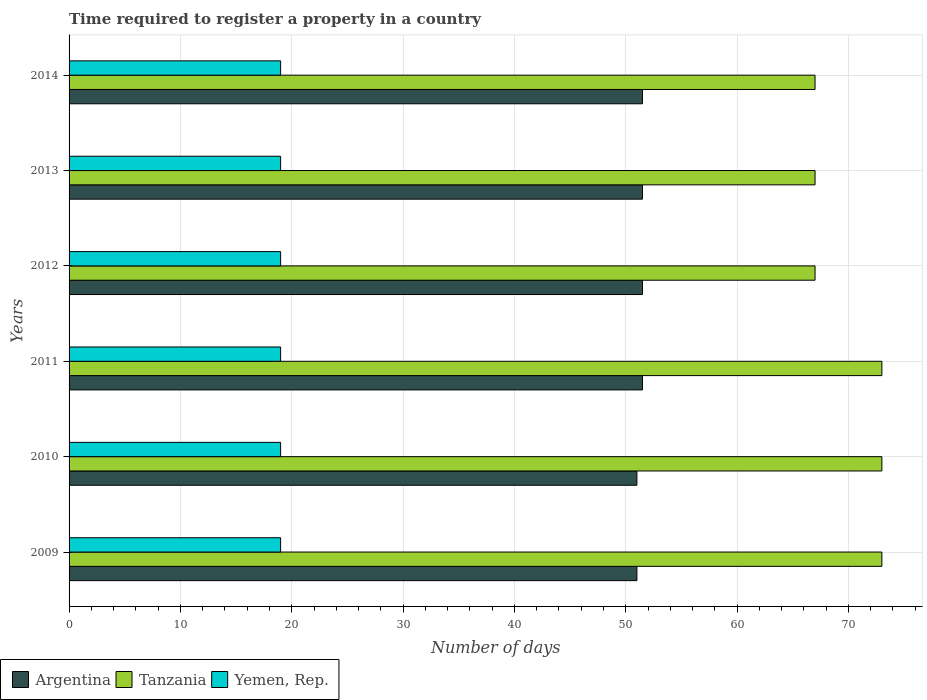How many different coloured bars are there?
Provide a succinct answer. 3. How many bars are there on the 3rd tick from the top?
Make the answer very short. 3. How many bars are there on the 6th tick from the bottom?
Offer a very short reply. 3. In how many cases, is the number of bars for a given year not equal to the number of legend labels?
Your answer should be compact. 0. Across all years, what is the maximum number of days required to register a property in Yemen, Rep.?
Keep it short and to the point. 19. Across all years, what is the minimum number of days required to register a property in Argentina?
Keep it short and to the point. 51. In which year was the number of days required to register a property in Tanzania minimum?
Give a very brief answer. 2012. What is the total number of days required to register a property in Argentina in the graph?
Ensure brevity in your answer.  308. What is the difference between the number of days required to register a property in Yemen, Rep. in 2011 and that in 2013?
Your response must be concise. 0. What is the difference between the number of days required to register a property in Yemen, Rep. in 2010 and the number of days required to register a property in Argentina in 2012?
Offer a terse response. -32.5. What is the ratio of the number of days required to register a property in Yemen, Rep. in 2009 to that in 2010?
Provide a short and direct response. 1. Is the number of days required to register a property in Argentina in 2011 less than that in 2014?
Your answer should be compact. No. Is the difference between the number of days required to register a property in Tanzania in 2012 and 2013 greater than the difference between the number of days required to register a property in Argentina in 2012 and 2013?
Offer a terse response. No. What is the difference between the highest and the second highest number of days required to register a property in Yemen, Rep.?
Offer a terse response. 0. Is the sum of the number of days required to register a property in Yemen, Rep. in 2010 and 2013 greater than the maximum number of days required to register a property in Tanzania across all years?
Provide a succinct answer. No. What does the 3rd bar from the bottom in 2012 represents?
Your answer should be very brief. Yemen, Rep. Are the values on the major ticks of X-axis written in scientific E-notation?
Your answer should be compact. No. Does the graph contain any zero values?
Ensure brevity in your answer.  No. Does the graph contain grids?
Keep it short and to the point. Yes. Where does the legend appear in the graph?
Your answer should be very brief. Bottom left. What is the title of the graph?
Your response must be concise. Time required to register a property in a country. What is the label or title of the X-axis?
Make the answer very short. Number of days. What is the label or title of the Y-axis?
Provide a succinct answer. Years. What is the Number of days in Tanzania in 2010?
Give a very brief answer. 73. What is the Number of days of Argentina in 2011?
Provide a succinct answer. 51.5. What is the Number of days in Argentina in 2012?
Provide a succinct answer. 51.5. What is the Number of days of Yemen, Rep. in 2012?
Give a very brief answer. 19. What is the Number of days of Argentina in 2013?
Provide a succinct answer. 51.5. What is the Number of days in Yemen, Rep. in 2013?
Give a very brief answer. 19. What is the Number of days of Argentina in 2014?
Provide a succinct answer. 51.5. What is the Number of days in Yemen, Rep. in 2014?
Your answer should be compact. 19. Across all years, what is the maximum Number of days in Argentina?
Keep it short and to the point. 51.5. Across all years, what is the maximum Number of days in Yemen, Rep.?
Your answer should be very brief. 19. Across all years, what is the minimum Number of days of Tanzania?
Your answer should be very brief. 67. Across all years, what is the minimum Number of days in Yemen, Rep.?
Your answer should be very brief. 19. What is the total Number of days in Argentina in the graph?
Offer a very short reply. 308. What is the total Number of days in Tanzania in the graph?
Give a very brief answer. 420. What is the total Number of days of Yemen, Rep. in the graph?
Keep it short and to the point. 114. What is the difference between the Number of days of Argentina in 2009 and that in 2010?
Your answer should be very brief. 0. What is the difference between the Number of days in Yemen, Rep. in 2009 and that in 2010?
Provide a succinct answer. 0. What is the difference between the Number of days in Yemen, Rep. in 2009 and that in 2011?
Offer a very short reply. 0. What is the difference between the Number of days in Argentina in 2009 and that in 2012?
Keep it short and to the point. -0.5. What is the difference between the Number of days of Argentina in 2009 and that in 2013?
Your answer should be compact. -0.5. What is the difference between the Number of days in Yemen, Rep. in 2009 and that in 2013?
Offer a very short reply. 0. What is the difference between the Number of days in Tanzania in 2009 and that in 2014?
Provide a succinct answer. 6. What is the difference between the Number of days of Yemen, Rep. in 2009 and that in 2014?
Offer a very short reply. 0. What is the difference between the Number of days in Argentina in 2010 and that in 2012?
Your answer should be compact. -0.5. What is the difference between the Number of days of Tanzania in 2010 and that in 2013?
Your answer should be very brief. 6. What is the difference between the Number of days of Argentina in 2010 and that in 2014?
Make the answer very short. -0.5. What is the difference between the Number of days of Tanzania in 2010 and that in 2014?
Offer a terse response. 6. What is the difference between the Number of days of Yemen, Rep. in 2010 and that in 2014?
Make the answer very short. 0. What is the difference between the Number of days in Argentina in 2011 and that in 2012?
Your answer should be compact. 0. What is the difference between the Number of days in Argentina in 2011 and that in 2013?
Provide a short and direct response. 0. What is the difference between the Number of days of Yemen, Rep. in 2011 and that in 2013?
Keep it short and to the point. 0. What is the difference between the Number of days of Tanzania in 2012 and that in 2014?
Your response must be concise. 0. What is the difference between the Number of days of Yemen, Rep. in 2012 and that in 2014?
Your answer should be compact. 0. What is the difference between the Number of days in Argentina in 2013 and that in 2014?
Make the answer very short. 0. What is the difference between the Number of days of Tanzania in 2013 and that in 2014?
Provide a succinct answer. 0. What is the difference between the Number of days in Argentina in 2009 and the Number of days in Tanzania in 2010?
Give a very brief answer. -22. What is the difference between the Number of days in Tanzania in 2009 and the Number of days in Yemen, Rep. in 2011?
Provide a short and direct response. 54. What is the difference between the Number of days in Argentina in 2009 and the Number of days in Tanzania in 2012?
Your answer should be very brief. -16. What is the difference between the Number of days of Argentina in 2009 and the Number of days of Yemen, Rep. in 2012?
Keep it short and to the point. 32. What is the difference between the Number of days of Argentina in 2009 and the Number of days of Tanzania in 2013?
Your answer should be very brief. -16. What is the difference between the Number of days of Tanzania in 2009 and the Number of days of Yemen, Rep. in 2013?
Give a very brief answer. 54. What is the difference between the Number of days in Argentina in 2009 and the Number of days in Tanzania in 2014?
Your answer should be very brief. -16. What is the difference between the Number of days in Argentina in 2009 and the Number of days in Yemen, Rep. in 2014?
Provide a succinct answer. 32. What is the difference between the Number of days in Tanzania in 2010 and the Number of days in Yemen, Rep. in 2011?
Your answer should be compact. 54. What is the difference between the Number of days of Argentina in 2010 and the Number of days of Tanzania in 2012?
Ensure brevity in your answer.  -16. What is the difference between the Number of days of Tanzania in 2010 and the Number of days of Yemen, Rep. in 2012?
Your answer should be very brief. 54. What is the difference between the Number of days of Tanzania in 2010 and the Number of days of Yemen, Rep. in 2014?
Provide a succinct answer. 54. What is the difference between the Number of days in Argentina in 2011 and the Number of days in Tanzania in 2012?
Provide a short and direct response. -15.5. What is the difference between the Number of days of Argentina in 2011 and the Number of days of Yemen, Rep. in 2012?
Provide a short and direct response. 32.5. What is the difference between the Number of days in Argentina in 2011 and the Number of days in Tanzania in 2013?
Provide a succinct answer. -15.5. What is the difference between the Number of days of Argentina in 2011 and the Number of days of Yemen, Rep. in 2013?
Your answer should be very brief. 32.5. What is the difference between the Number of days of Argentina in 2011 and the Number of days of Tanzania in 2014?
Keep it short and to the point. -15.5. What is the difference between the Number of days in Argentina in 2011 and the Number of days in Yemen, Rep. in 2014?
Keep it short and to the point. 32.5. What is the difference between the Number of days in Argentina in 2012 and the Number of days in Tanzania in 2013?
Provide a succinct answer. -15.5. What is the difference between the Number of days in Argentina in 2012 and the Number of days in Yemen, Rep. in 2013?
Give a very brief answer. 32.5. What is the difference between the Number of days of Argentina in 2012 and the Number of days of Tanzania in 2014?
Provide a short and direct response. -15.5. What is the difference between the Number of days in Argentina in 2012 and the Number of days in Yemen, Rep. in 2014?
Offer a very short reply. 32.5. What is the difference between the Number of days of Argentina in 2013 and the Number of days of Tanzania in 2014?
Your answer should be compact. -15.5. What is the difference between the Number of days in Argentina in 2013 and the Number of days in Yemen, Rep. in 2014?
Make the answer very short. 32.5. What is the average Number of days in Argentina per year?
Give a very brief answer. 51.33. What is the average Number of days of Tanzania per year?
Provide a succinct answer. 70. What is the average Number of days in Yemen, Rep. per year?
Provide a succinct answer. 19. In the year 2009, what is the difference between the Number of days in Argentina and Number of days in Yemen, Rep.?
Offer a terse response. 32. In the year 2009, what is the difference between the Number of days in Tanzania and Number of days in Yemen, Rep.?
Your answer should be compact. 54. In the year 2010, what is the difference between the Number of days of Argentina and Number of days of Tanzania?
Ensure brevity in your answer.  -22. In the year 2011, what is the difference between the Number of days of Argentina and Number of days of Tanzania?
Provide a short and direct response. -21.5. In the year 2011, what is the difference between the Number of days of Argentina and Number of days of Yemen, Rep.?
Keep it short and to the point. 32.5. In the year 2012, what is the difference between the Number of days of Argentina and Number of days of Tanzania?
Make the answer very short. -15.5. In the year 2012, what is the difference between the Number of days in Argentina and Number of days in Yemen, Rep.?
Provide a short and direct response. 32.5. In the year 2013, what is the difference between the Number of days in Argentina and Number of days in Tanzania?
Provide a short and direct response. -15.5. In the year 2013, what is the difference between the Number of days of Argentina and Number of days of Yemen, Rep.?
Offer a very short reply. 32.5. In the year 2014, what is the difference between the Number of days in Argentina and Number of days in Tanzania?
Provide a succinct answer. -15.5. In the year 2014, what is the difference between the Number of days of Argentina and Number of days of Yemen, Rep.?
Ensure brevity in your answer.  32.5. What is the ratio of the Number of days in Argentina in 2009 to that in 2010?
Give a very brief answer. 1. What is the ratio of the Number of days in Tanzania in 2009 to that in 2010?
Your answer should be compact. 1. What is the ratio of the Number of days in Argentina in 2009 to that in 2011?
Make the answer very short. 0.99. What is the ratio of the Number of days of Argentina in 2009 to that in 2012?
Your response must be concise. 0.99. What is the ratio of the Number of days of Tanzania in 2009 to that in 2012?
Keep it short and to the point. 1.09. What is the ratio of the Number of days in Argentina in 2009 to that in 2013?
Provide a succinct answer. 0.99. What is the ratio of the Number of days in Tanzania in 2009 to that in 2013?
Provide a succinct answer. 1.09. What is the ratio of the Number of days of Argentina in 2009 to that in 2014?
Offer a terse response. 0.99. What is the ratio of the Number of days of Tanzania in 2009 to that in 2014?
Make the answer very short. 1.09. What is the ratio of the Number of days of Yemen, Rep. in 2009 to that in 2014?
Make the answer very short. 1. What is the ratio of the Number of days of Argentina in 2010 to that in 2011?
Make the answer very short. 0.99. What is the ratio of the Number of days in Tanzania in 2010 to that in 2011?
Your response must be concise. 1. What is the ratio of the Number of days of Yemen, Rep. in 2010 to that in 2011?
Your response must be concise. 1. What is the ratio of the Number of days in Argentina in 2010 to that in 2012?
Give a very brief answer. 0.99. What is the ratio of the Number of days of Tanzania in 2010 to that in 2012?
Your answer should be compact. 1.09. What is the ratio of the Number of days of Argentina in 2010 to that in 2013?
Give a very brief answer. 0.99. What is the ratio of the Number of days of Tanzania in 2010 to that in 2013?
Your answer should be compact. 1.09. What is the ratio of the Number of days of Yemen, Rep. in 2010 to that in 2013?
Provide a short and direct response. 1. What is the ratio of the Number of days of Argentina in 2010 to that in 2014?
Provide a short and direct response. 0.99. What is the ratio of the Number of days in Tanzania in 2010 to that in 2014?
Offer a very short reply. 1.09. What is the ratio of the Number of days in Argentina in 2011 to that in 2012?
Make the answer very short. 1. What is the ratio of the Number of days of Tanzania in 2011 to that in 2012?
Ensure brevity in your answer.  1.09. What is the ratio of the Number of days of Argentina in 2011 to that in 2013?
Give a very brief answer. 1. What is the ratio of the Number of days of Tanzania in 2011 to that in 2013?
Provide a short and direct response. 1.09. What is the ratio of the Number of days in Yemen, Rep. in 2011 to that in 2013?
Your answer should be very brief. 1. What is the ratio of the Number of days in Argentina in 2011 to that in 2014?
Offer a very short reply. 1. What is the ratio of the Number of days of Tanzania in 2011 to that in 2014?
Your answer should be very brief. 1.09. What is the ratio of the Number of days of Tanzania in 2012 to that in 2013?
Your answer should be compact. 1. What is the ratio of the Number of days in Yemen, Rep. in 2012 to that in 2013?
Your answer should be compact. 1. What is the ratio of the Number of days in Argentina in 2012 to that in 2014?
Give a very brief answer. 1. What is the ratio of the Number of days of Yemen, Rep. in 2012 to that in 2014?
Offer a very short reply. 1. What is the ratio of the Number of days of Tanzania in 2013 to that in 2014?
Your response must be concise. 1. What is the difference between the highest and the lowest Number of days in Tanzania?
Offer a very short reply. 6. 